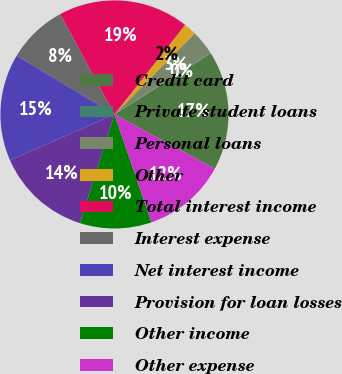Convert chart to OTSL. <chart><loc_0><loc_0><loc_500><loc_500><pie_chart><fcel>Credit card<fcel>Private student loans<fcel>Personal loans<fcel>Other<fcel>Total interest income<fcel>Interest expense<fcel>Net interest income<fcel>Provision for loan losses<fcel>Other income<fcel>Other expense<nl><fcel>16.86%<fcel>0.13%<fcel>3.48%<fcel>1.8%<fcel>18.53%<fcel>8.49%<fcel>15.19%<fcel>13.51%<fcel>10.17%<fcel>11.84%<nl></chart> 